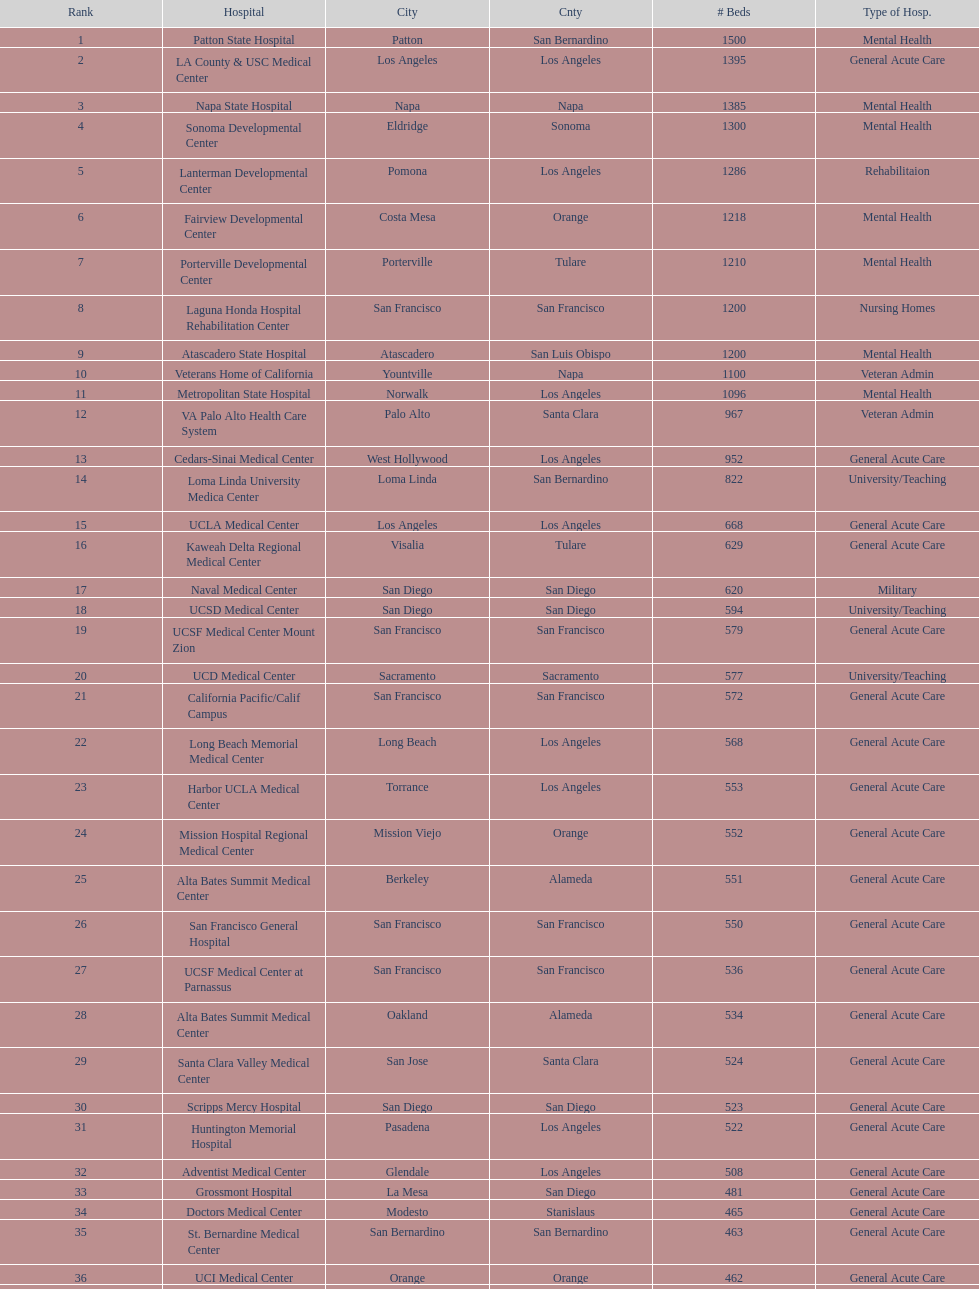How many hospital's have at least 600 beds? 17. 